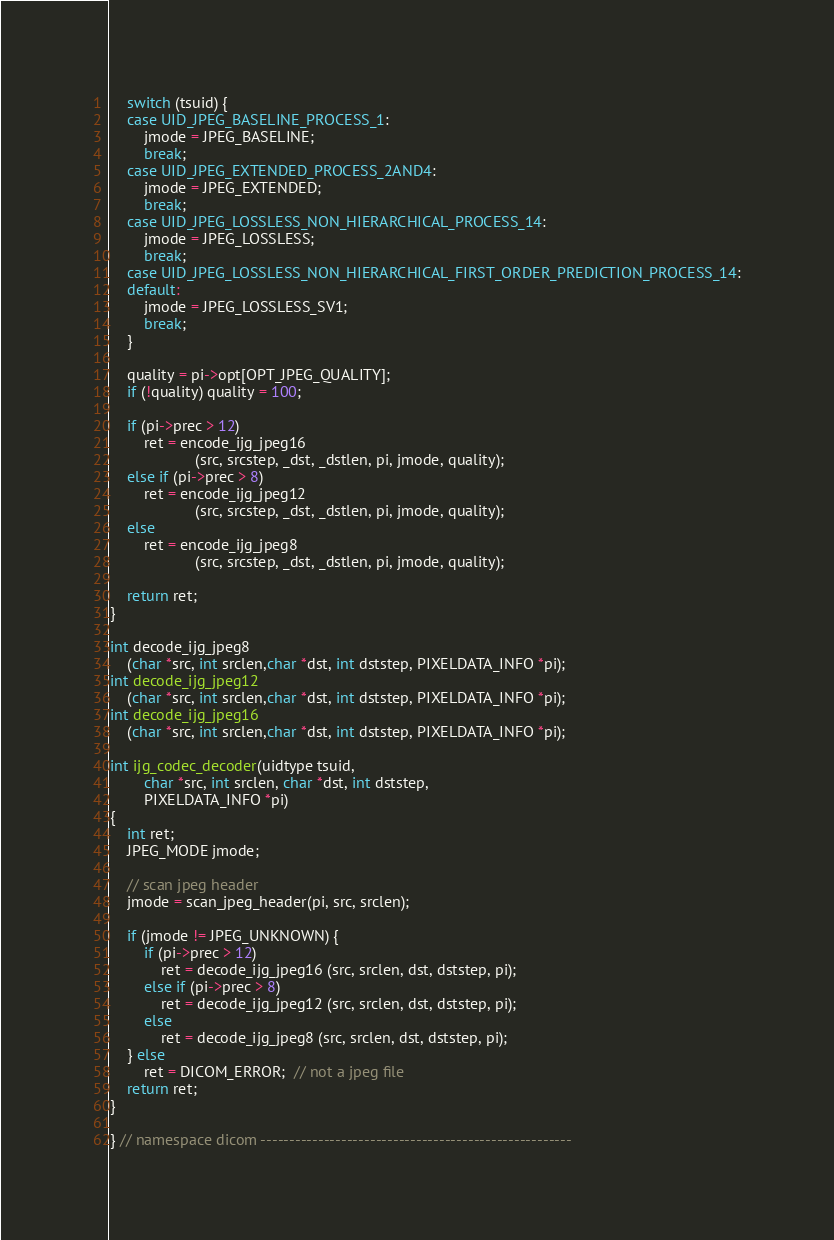Convert code to text. <code><loc_0><loc_0><loc_500><loc_500><_C++_>
	switch (tsuid) {
	case UID_JPEG_BASELINE_PROCESS_1:
		jmode = JPEG_BASELINE;
		break;
	case UID_JPEG_EXTENDED_PROCESS_2AND4:
		jmode = JPEG_EXTENDED;
		break;
	case UID_JPEG_LOSSLESS_NON_HIERARCHICAL_PROCESS_14:
		jmode = JPEG_LOSSLESS;
		break;
	case UID_JPEG_LOSSLESS_NON_HIERARCHICAL_FIRST_ORDER_PREDICTION_PROCESS_14:
	default:
		jmode = JPEG_LOSSLESS_SV1;
		break;
	}

	quality = pi->opt[OPT_JPEG_QUALITY];
	if (!quality) quality = 100;

	if (pi->prec > 12)
		ret = encode_ijg_jpeg16
					(src, srcstep, _dst, _dstlen, pi, jmode, quality);
	else if (pi->prec > 8)
		ret = encode_ijg_jpeg12
					(src, srcstep, _dst, _dstlen, pi, jmode, quality);
	else
		ret = encode_ijg_jpeg8
					(src, srcstep, _dst, _dstlen, pi, jmode, quality);

	return ret;
}

int decode_ijg_jpeg8
	(char *src, int srclen,char *dst, int dststep, PIXELDATA_INFO *pi);
int decode_ijg_jpeg12
	(char *src, int srclen,char *dst, int dststep, PIXELDATA_INFO *pi);
int decode_ijg_jpeg16
	(char *src, int srclen,char *dst, int dststep, PIXELDATA_INFO *pi);

int ijg_codec_decoder(uidtype tsuid,
		char *src, int srclen, char *dst, int dststep,
		PIXELDATA_INFO *pi)
{
	int ret;
	JPEG_MODE jmode;

	// scan jpeg header
	jmode = scan_jpeg_header(pi, src, srclen);

	if (jmode != JPEG_UNKNOWN) {
		if (pi->prec > 12)
			ret = decode_ijg_jpeg16 (src, srclen, dst, dststep, pi);
		else if (pi->prec > 8)
			ret = decode_ijg_jpeg12 (src, srclen, dst, dststep, pi);
		else
			ret = decode_ijg_jpeg8 (src, srclen, dst, dststep, pi);
	} else
		ret = DICOM_ERROR;  // not a jpeg file
	return ret;
}

} // namespace dicom ------------------------------------------------------
</code> 